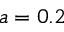<formula> <loc_0><loc_0><loc_500><loc_500>a = 0 . 2</formula> 